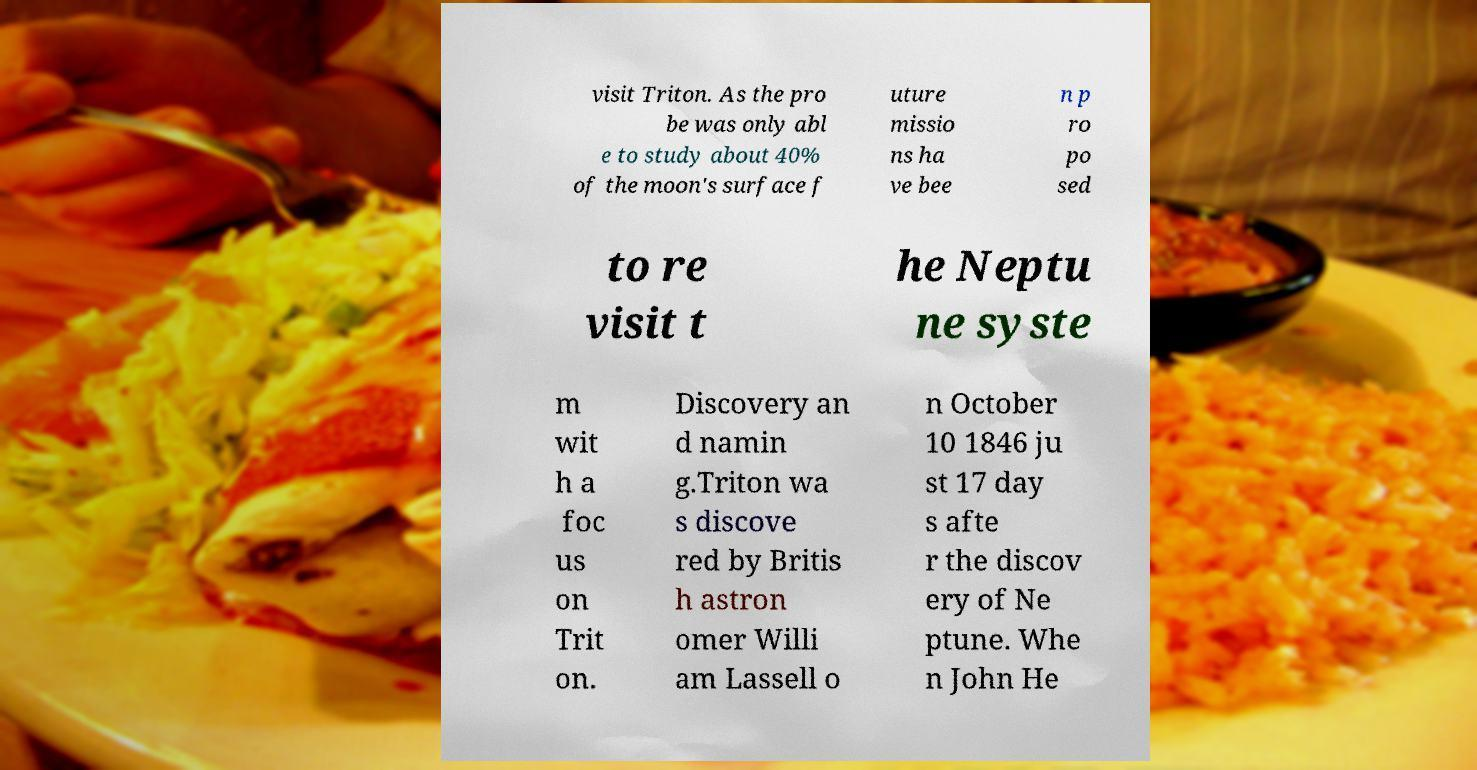Could you extract and type out the text from this image? visit Triton. As the pro be was only abl e to study about 40% of the moon's surface f uture missio ns ha ve bee n p ro po sed to re visit t he Neptu ne syste m wit h a foc us on Trit on. Discovery an d namin g.Triton wa s discove red by Britis h astron omer Willi am Lassell o n October 10 1846 ju st 17 day s afte r the discov ery of Ne ptune. Whe n John He 